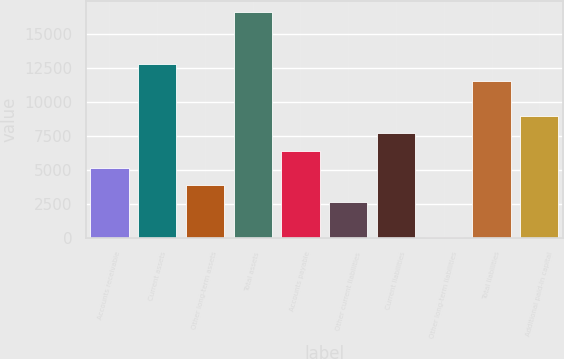<chart> <loc_0><loc_0><loc_500><loc_500><bar_chart><fcel>Accounts receivable<fcel>Current assets<fcel>Other long-term assets<fcel>Total assets<fcel>Accounts payable<fcel>Other current liabilities<fcel>Current liabilities<fcel>Other long-term liabilities<fcel>Total liabilities<fcel>Additional paid-in capital<nl><fcel>5161.2<fcel>12810<fcel>3886.4<fcel>16634.4<fcel>6436<fcel>2611.6<fcel>7710.8<fcel>62<fcel>11535.2<fcel>8985.6<nl></chart> 